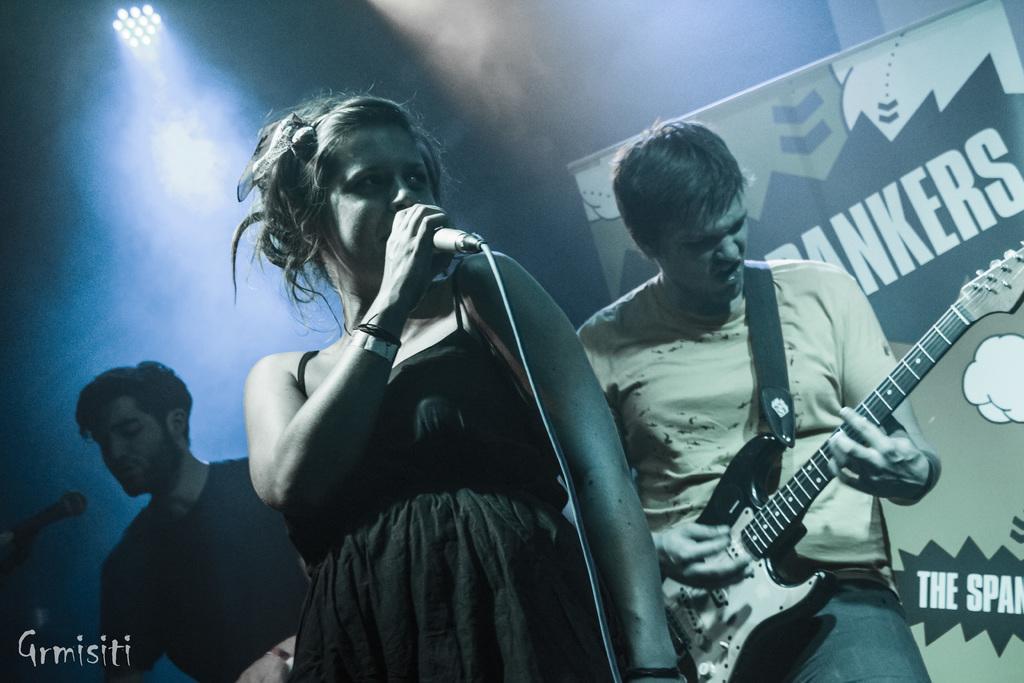Describe this image in one or two sentences. There are three persons standing,two people are singing song and person is holding and playing guitar. This looks like a banner at the background. This is the show lights at the top of the image. 